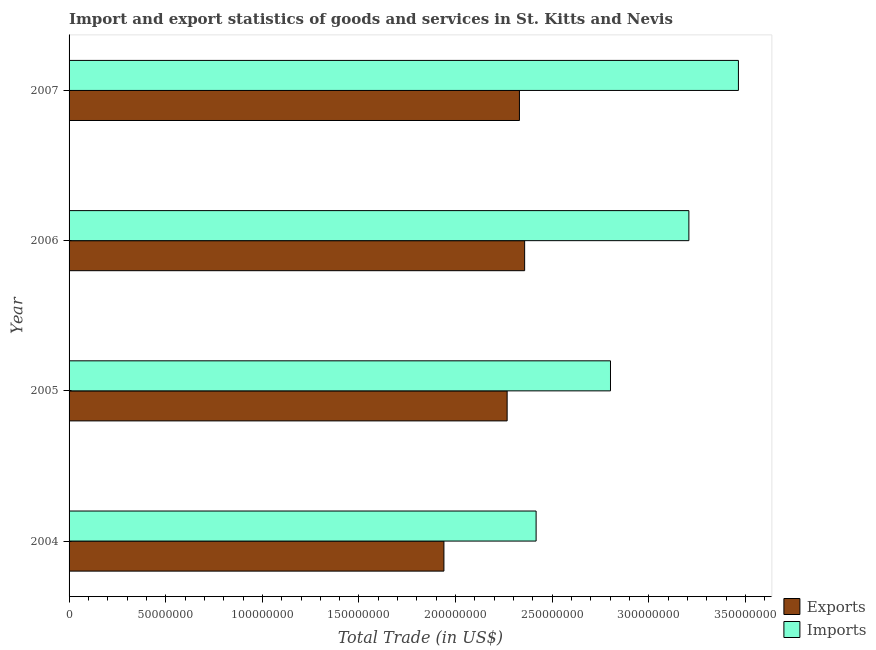How many groups of bars are there?
Offer a terse response. 4. Are the number of bars per tick equal to the number of legend labels?
Offer a very short reply. Yes. Are the number of bars on each tick of the Y-axis equal?
Make the answer very short. Yes. How many bars are there on the 3rd tick from the top?
Your answer should be compact. 2. What is the label of the 3rd group of bars from the top?
Offer a terse response. 2005. In how many cases, is the number of bars for a given year not equal to the number of legend labels?
Make the answer very short. 0. What is the export of goods and services in 2007?
Your answer should be compact. 2.33e+08. Across all years, what is the maximum export of goods and services?
Provide a short and direct response. 2.36e+08. Across all years, what is the minimum imports of goods and services?
Offer a very short reply. 2.42e+08. In which year was the export of goods and services maximum?
Offer a very short reply. 2006. In which year was the imports of goods and services minimum?
Your response must be concise. 2004. What is the total export of goods and services in the graph?
Ensure brevity in your answer.  8.89e+08. What is the difference between the export of goods and services in 2005 and that in 2007?
Offer a very short reply. -6.36e+06. What is the difference between the imports of goods and services in 2004 and the export of goods and services in 2005?
Your answer should be compact. 1.50e+07. What is the average imports of goods and services per year?
Give a very brief answer. 2.97e+08. In the year 2005, what is the difference between the export of goods and services and imports of goods and services?
Make the answer very short. -5.35e+07. In how many years, is the imports of goods and services greater than 20000000 US$?
Keep it short and to the point. 4. What is the ratio of the imports of goods and services in 2004 to that in 2006?
Keep it short and to the point. 0.75. Is the imports of goods and services in 2005 less than that in 2007?
Offer a very short reply. Yes. Is the difference between the imports of goods and services in 2005 and 2007 greater than the difference between the export of goods and services in 2005 and 2007?
Offer a very short reply. No. What is the difference between the highest and the second highest imports of goods and services?
Ensure brevity in your answer.  2.56e+07. What is the difference between the highest and the lowest export of goods and services?
Your answer should be very brief. 4.18e+07. Is the sum of the imports of goods and services in 2004 and 2007 greater than the maximum export of goods and services across all years?
Give a very brief answer. Yes. What does the 1st bar from the top in 2004 represents?
Provide a succinct answer. Imports. What does the 2nd bar from the bottom in 2007 represents?
Provide a succinct answer. Imports. What is the difference between two consecutive major ticks on the X-axis?
Give a very brief answer. 5.00e+07. Does the graph contain any zero values?
Give a very brief answer. No. Does the graph contain grids?
Make the answer very short. No. Where does the legend appear in the graph?
Your answer should be very brief. Bottom right. How are the legend labels stacked?
Your answer should be very brief. Vertical. What is the title of the graph?
Keep it short and to the point. Import and export statistics of goods and services in St. Kitts and Nevis. What is the label or title of the X-axis?
Make the answer very short. Total Trade (in US$). What is the Total Trade (in US$) in Exports in 2004?
Ensure brevity in your answer.  1.94e+08. What is the Total Trade (in US$) in Imports in 2004?
Offer a terse response. 2.42e+08. What is the Total Trade (in US$) of Exports in 2005?
Give a very brief answer. 2.27e+08. What is the Total Trade (in US$) in Imports in 2005?
Make the answer very short. 2.80e+08. What is the Total Trade (in US$) in Exports in 2006?
Offer a terse response. 2.36e+08. What is the Total Trade (in US$) of Imports in 2006?
Provide a succinct answer. 3.21e+08. What is the Total Trade (in US$) in Exports in 2007?
Make the answer very short. 2.33e+08. What is the Total Trade (in US$) in Imports in 2007?
Give a very brief answer. 3.46e+08. Across all years, what is the maximum Total Trade (in US$) of Exports?
Your answer should be compact. 2.36e+08. Across all years, what is the maximum Total Trade (in US$) in Imports?
Provide a succinct answer. 3.46e+08. Across all years, what is the minimum Total Trade (in US$) of Exports?
Provide a short and direct response. 1.94e+08. Across all years, what is the minimum Total Trade (in US$) of Imports?
Offer a very short reply. 2.42e+08. What is the total Total Trade (in US$) of Exports in the graph?
Make the answer very short. 8.89e+08. What is the total Total Trade (in US$) in Imports in the graph?
Give a very brief answer. 1.19e+09. What is the difference between the Total Trade (in US$) in Exports in 2004 and that in 2005?
Offer a very short reply. -3.27e+07. What is the difference between the Total Trade (in US$) in Imports in 2004 and that in 2005?
Provide a succinct answer. -3.85e+07. What is the difference between the Total Trade (in US$) of Exports in 2004 and that in 2006?
Your response must be concise. -4.18e+07. What is the difference between the Total Trade (in US$) of Imports in 2004 and that in 2006?
Your answer should be compact. -7.90e+07. What is the difference between the Total Trade (in US$) in Exports in 2004 and that in 2007?
Provide a succinct answer. -3.91e+07. What is the difference between the Total Trade (in US$) of Imports in 2004 and that in 2007?
Offer a terse response. -1.05e+08. What is the difference between the Total Trade (in US$) in Exports in 2005 and that in 2006?
Ensure brevity in your answer.  -9.05e+06. What is the difference between the Total Trade (in US$) in Imports in 2005 and that in 2006?
Offer a terse response. -4.06e+07. What is the difference between the Total Trade (in US$) in Exports in 2005 and that in 2007?
Your answer should be compact. -6.36e+06. What is the difference between the Total Trade (in US$) in Imports in 2005 and that in 2007?
Offer a terse response. -6.62e+07. What is the difference between the Total Trade (in US$) in Exports in 2006 and that in 2007?
Offer a very short reply. 2.69e+06. What is the difference between the Total Trade (in US$) in Imports in 2006 and that in 2007?
Give a very brief answer. -2.56e+07. What is the difference between the Total Trade (in US$) of Exports in 2004 and the Total Trade (in US$) of Imports in 2005?
Your answer should be compact. -8.62e+07. What is the difference between the Total Trade (in US$) of Exports in 2004 and the Total Trade (in US$) of Imports in 2006?
Offer a terse response. -1.27e+08. What is the difference between the Total Trade (in US$) in Exports in 2004 and the Total Trade (in US$) in Imports in 2007?
Your answer should be very brief. -1.52e+08. What is the difference between the Total Trade (in US$) of Exports in 2005 and the Total Trade (in US$) of Imports in 2006?
Provide a short and direct response. -9.40e+07. What is the difference between the Total Trade (in US$) of Exports in 2005 and the Total Trade (in US$) of Imports in 2007?
Provide a succinct answer. -1.20e+08. What is the difference between the Total Trade (in US$) of Exports in 2006 and the Total Trade (in US$) of Imports in 2007?
Keep it short and to the point. -1.11e+08. What is the average Total Trade (in US$) of Exports per year?
Keep it short and to the point. 2.22e+08. What is the average Total Trade (in US$) in Imports per year?
Ensure brevity in your answer.  2.97e+08. In the year 2004, what is the difference between the Total Trade (in US$) in Exports and Total Trade (in US$) in Imports?
Offer a very short reply. -4.77e+07. In the year 2005, what is the difference between the Total Trade (in US$) of Exports and Total Trade (in US$) of Imports?
Give a very brief answer. -5.35e+07. In the year 2006, what is the difference between the Total Trade (in US$) in Exports and Total Trade (in US$) in Imports?
Provide a short and direct response. -8.50e+07. In the year 2007, what is the difference between the Total Trade (in US$) of Exports and Total Trade (in US$) of Imports?
Make the answer very short. -1.13e+08. What is the ratio of the Total Trade (in US$) of Exports in 2004 to that in 2005?
Offer a terse response. 0.86. What is the ratio of the Total Trade (in US$) of Imports in 2004 to that in 2005?
Provide a short and direct response. 0.86. What is the ratio of the Total Trade (in US$) in Exports in 2004 to that in 2006?
Offer a very short reply. 0.82. What is the ratio of the Total Trade (in US$) in Imports in 2004 to that in 2006?
Keep it short and to the point. 0.75. What is the ratio of the Total Trade (in US$) in Exports in 2004 to that in 2007?
Keep it short and to the point. 0.83. What is the ratio of the Total Trade (in US$) in Imports in 2004 to that in 2007?
Ensure brevity in your answer.  0.7. What is the ratio of the Total Trade (in US$) in Exports in 2005 to that in 2006?
Keep it short and to the point. 0.96. What is the ratio of the Total Trade (in US$) of Imports in 2005 to that in 2006?
Ensure brevity in your answer.  0.87. What is the ratio of the Total Trade (in US$) in Exports in 2005 to that in 2007?
Make the answer very short. 0.97. What is the ratio of the Total Trade (in US$) in Imports in 2005 to that in 2007?
Ensure brevity in your answer.  0.81. What is the ratio of the Total Trade (in US$) of Exports in 2006 to that in 2007?
Provide a succinct answer. 1.01. What is the ratio of the Total Trade (in US$) of Imports in 2006 to that in 2007?
Your response must be concise. 0.93. What is the difference between the highest and the second highest Total Trade (in US$) of Exports?
Make the answer very short. 2.69e+06. What is the difference between the highest and the second highest Total Trade (in US$) of Imports?
Offer a terse response. 2.56e+07. What is the difference between the highest and the lowest Total Trade (in US$) of Exports?
Your response must be concise. 4.18e+07. What is the difference between the highest and the lowest Total Trade (in US$) of Imports?
Provide a succinct answer. 1.05e+08. 